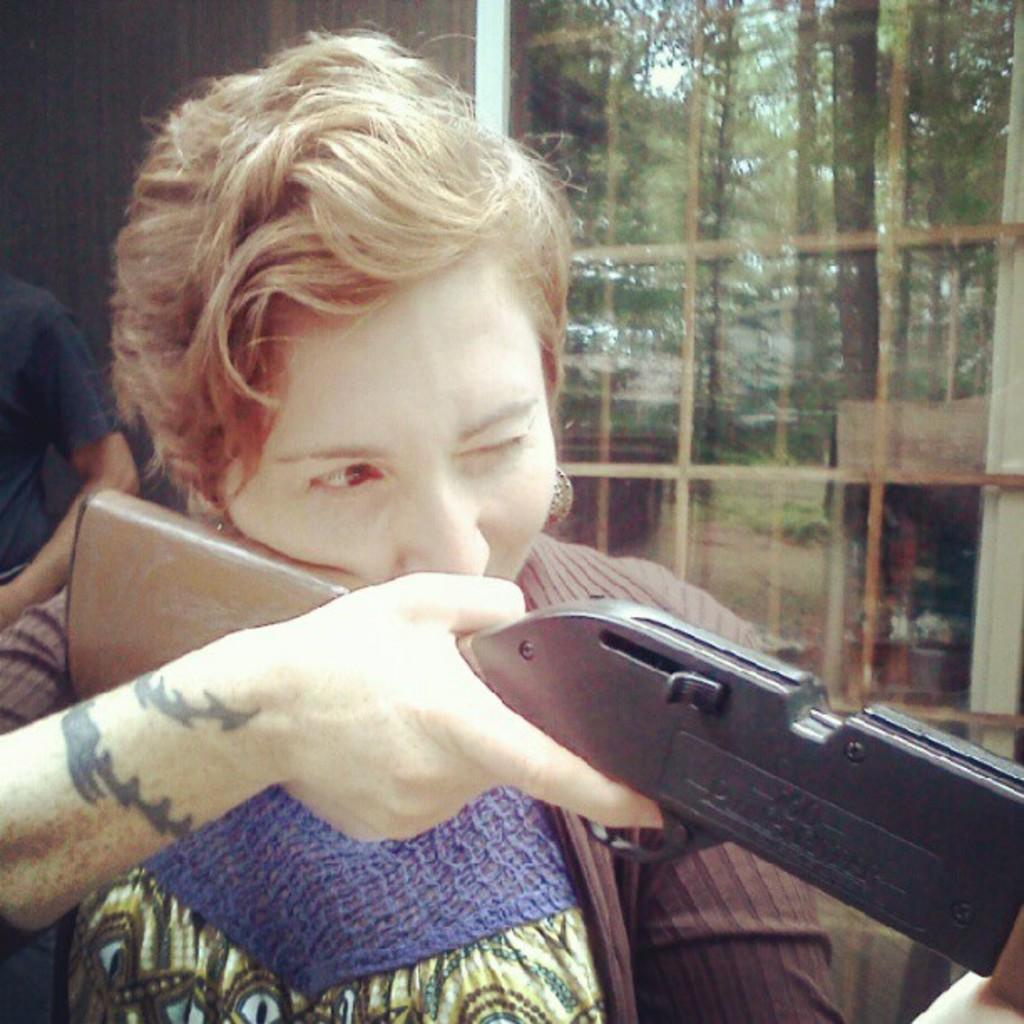Who is present in the image? There is a woman in the image. What is the woman holding in the image? The woman is holding a gun. Can you describe the background of the image? There is a person, a wall, a glass object, trees, rods, and other objects visible through the glass in the background of the image. What type of cloth is being used to cover the table during the feast in the image? There is no feast or cloth present in the image. What type of haircut does the woman have in the image? The image does not show the woman's haircut. 